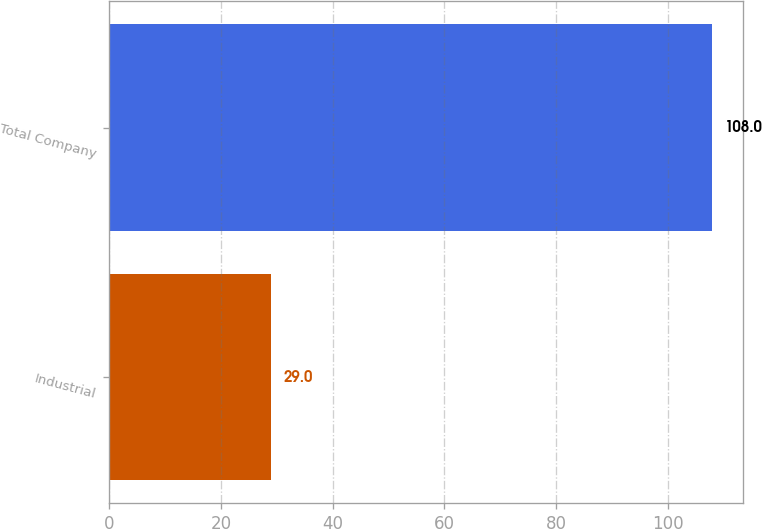Convert chart to OTSL. <chart><loc_0><loc_0><loc_500><loc_500><bar_chart><fcel>Industrial<fcel>Total Company<nl><fcel>29<fcel>108<nl></chart> 